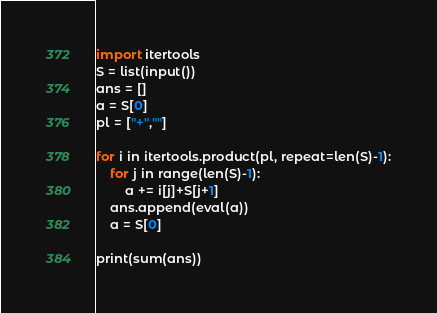Convert code to text. <code><loc_0><loc_0><loc_500><loc_500><_Python_>import itertools
S = list(input())
ans = []
a = S[0]
pl = ["+",""]

for i in itertools.product(pl, repeat=len(S)-1):
    for j in range(len(S)-1):
        a += i[j]+S[j+1]
    ans.append(eval(a))
    a = S[0]

print(sum(ans))</code> 